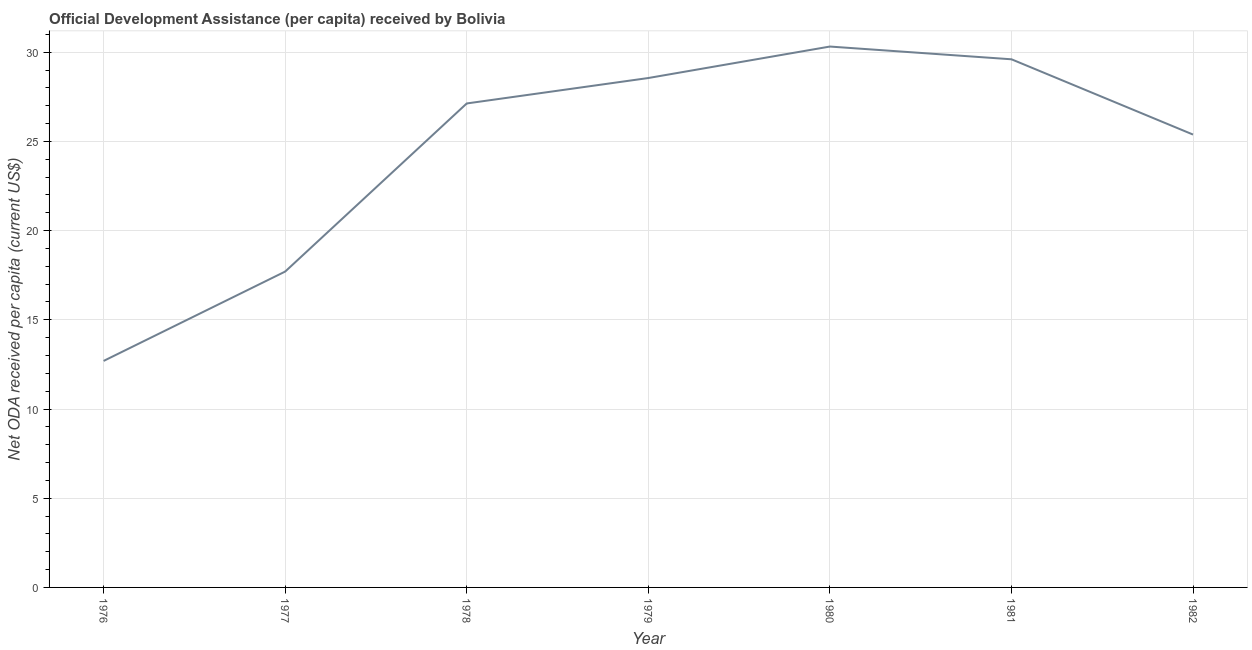What is the net oda received per capita in 1981?
Provide a short and direct response. 29.6. Across all years, what is the maximum net oda received per capita?
Make the answer very short. 30.32. Across all years, what is the minimum net oda received per capita?
Your response must be concise. 12.7. In which year was the net oda received per capita maximum?
Your answer should be very brief. 1980. In which year was the net oda received per capita minimum?
Keep it short and to the point. 1976. What is the sum of the net oda received per capita?
Your answer should be compact. 171.38. What is the difference between the net oda received per capita in 1976 and 1978?
Your response must be concise. -14.43. What is the average net oda received per capita per year?
Your answer should be very brief. 24.48. What is the median net oda received per capita?
Make the answer very short. 27.13. What is the ratio of the net oda received per capita in 1976 to that in 1982?
Offer a terse response. 0.5. What is the difference between the highest and the second highest net oda received per capita?
Keep it short and to the point. 0.71. What is the difference between the highest and the lowest net oda received per capita?
Keep it short and to the point. 17.62. In how many years, is the net oda received per capita greater than the average net oda received per capita taken over all years?
Ensure brevity in your answer.  5. Does the net oda received per capita monotonically increase over the years?
Your answer should be very brief. No. Does the graph contain any zero values?
Offer a very short reply. No. What is the title of the graph?
Ensure brevity in your answer.  Official Development Assistance (per capita) received by Bolivia. What is the label or title of the X-axis?
Give a very brief answer. Year. What is the label or title of the Y-axis?
Give a very brief answer. Net ODA received per capita (current US$). What is the Net ODA received per capita (current US$) in 1976?
Your answer should be compact. 12.7. What is the Net ODA received per capita (current US$) of 1977?
Offer a terse response. 17.7. What is the Net ODA received per capita (current US$) of 1978?
Your answer should be very brief. 27.13. What is the Net ODA received per capita (current US$) in 1979?
Your response must be concise. 28.55. What is the Net ODA received per capita (current US$) of 1980?
Give a very brief answer. 30.32. What is the Net ODA received per capita (current US$) in 1981?
Provide a succinct answer. 29.6. What is the Net ODA received per capita (current US$) in 1982?
Keep it short and to the point. 25.38. What is the difference between the Net ODA received per capita (current US$) in 1976 and 1977?
Provide a short and direct response. -5.01. What is the difference between the Net ODA received per capita (current US$) in 1976 and 1978?
Offer a terse response. -14.43. What is the difference between the Net ODA received per capita (current US$) in 1976 and 1979?
Ensure brevity in your answer.  -15.86. What is the difference between the Net ODA received per capita (current US$) in 1976 and 1980?
Your answer should be very brief. -17.62. What is the difference between the Net ODA received per capita (current US$) in 1976 and 1981?
Give a very brief answer. -16.91. What is the difference between the Net ODA received per capita (current US$) in 1976 and 1982?
Make the answer very short. -12.69. What is the difference between the Net ODA received per capita (current US$) in 1977 and 1978?
Offer a very short reply. -9.42. What is the difference between the Net ODA received per capita (current US$) in 1977 and 1979?
Make the answer very short. -10.85. What is the difference between the Net ODA received per capita (current US$) in 1977 and 1980?
Offer a very short reply. -12.61. What is the difference between the Net ODA received per capita (current US$) in 1977 and 1981?
Provide a succinct answer. -11.9. What is the difference between the Net ODA received per capita (current US$) in 1977 and 1982?
Your answer should be compact. -7.68. What is the difference between the Net ODA received per capita (current US$) in 1978 and 1979?
Your answer should be very brief. -1.43. What is the difference between the Net ODA received per capita (current US$) in 1978 and 1980?
Offer a terse response. -3.19. What is the difference between the Net ODA received per capita (current US$) in 1978 and 1981?
Give a very brief answer. -2.48. What is the difference between the Net ODA received per capita (current US$) in 1978 and 1982?
Make the answer very short. 1.74. What is the difference between the Net ODA received per capita (current US$) in 1979 and 1980?
Keep it short and to the point. -1.76. What is the difference between the Net ODA received per capita (current US$) in 1979 and 1981?
Your response must be concise. -1.05. What is the difference between the Net ODA received per capita (current US$) in 1979 and 1982?
Give a very brief answer. 3.17. What is the difference between the Net ODA received per capita (current US$) in 1980 and 1981?
Your response must be concise. 0.71. What is the difference between the Net ODA received per capita (current US$) in 1980 and 1982?
Keep it short and to the point. 4.93. What is the difference between the Net ODA received per capita (current US$) in 1981 and 1982?
Offer a very short reply. 4.22. What is the ratio of the Net ODA received per capita (current US$) in 1976 to that in 1977?
Your response must be concise. 0.72. What is the ratio of the Net ODA received per capita (current US$) in 1976 to that in 1978?
Keep it short and to the point. 0.47. What is the ratio of the Net ODA received per capita (current US$) in 1976 to that in 1979?
Provide a short and direct response. 0.45. What is the ratio of the Net ODA received per capita (current US$) in 1976 to that in 1980?
Make the answer very short. 0.42. What is the ratio of the Net ODA received per capita (current US$) in 1976 to that in 1981?
Ensure brevity in your answer.  0.43. What is the ratio of the Net ODA received per capita (current US$) in 1976 to that in 1982?
Make the answer very short. 0.5. What is the ratio of the Net ODA received per capita (current US$) in 1977 to that in 1978?
Your response must be concise. 0.65. What is the ratio of the Net ODA received per capita (current US$) in 1977 to that in 1979?
Give a very brief answer. 0.62. What is the ratio of the Net ODA received per capita (current US$) in 1977 to that in 1980?
Keep it short and to the point. 0.58. What is the ratio of the Net ODA received per capita (current US$) in 1977 to that in 1981?
Offer a terse response. 0.6. What is the ratio of the Net ODA received per capita (current US$) in 1977 to that in 1982?
Provide a short and direct response. 0.7. What is the ratio of the Net ODA received per capita (current US$) in 1978 to that in 1979?
Offer a terse response. 0.95. What is the ratio of the Net ODA received per capita (current US$) in 1978 to that in 1980?
Ensure brevity in your answer.  0.9. What is the ratio of the Net ODA received per capita (current US$) in 1978 to that in 1981?
Offer a very short reply. 0.92. What is the ratio of the Net ODA received per capita (current US$) in 1978 to that in 1982?
Your answer should be compact. 1.07. What is the ratio of the Net ODA received per capita (current US$) in 1979 to that in 1980?
Provide a short and direct response. 0.94. What is the ratio of the Net ODA received per capita (current US$) in 1979 to that in 1981?
Your response must be concise. 0.96. What is the ratio of the Net ODA received per capita (current US$) in 1979 to that in 1982?
Offer a very short reply. 1.12. What is the ratio of the Net ODA received per capita (current US$) in 1980 to that in 1981?
Ensure brevity in your answer.  1.02. What is the ratio of the Net ODA received per capita (current US$) in 1980 to that in 1982?
Make the answer very short. 1.19. What is the ratio of the Net ODA received per capita (current US$) in 1981 to that in 1982?
Your answer should be compact. 1.17. 